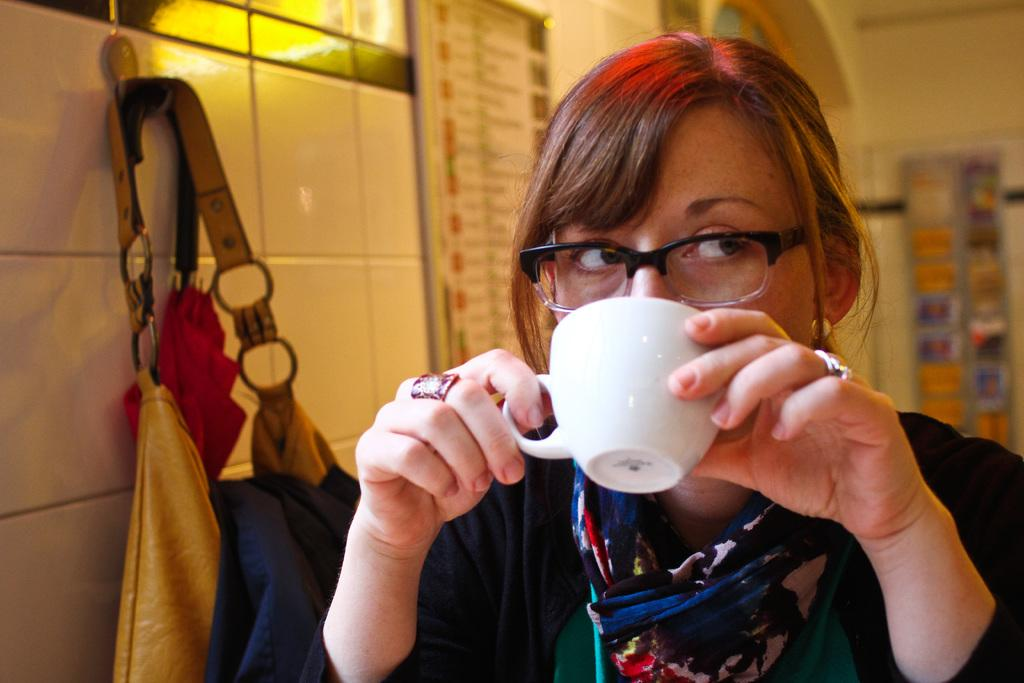Who is the main subject in the image? There is a woman in the image. What is the woman doing in the image? The woman is drinking coffee from a cup. What accessory is the woman wearing in the image? The woman is wearing spectacles. What type of animal can be seen rolling on the floor in the image? There is no animal present in the image, and therefore no such activity can be observed. 